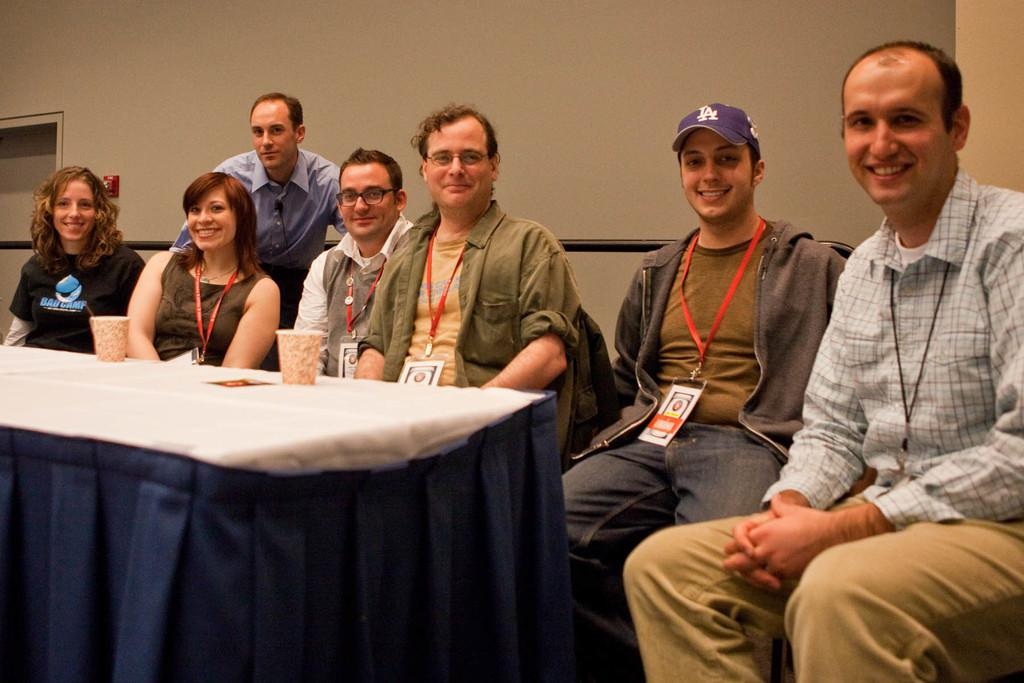Who or what is present in the image? There are people in the image. What are the people doing in the image? The people are sitting in front of a table. What objects can be seen on the table? There are coffee mugs on the table. What might indicate that the people in the image are part of an organization or workplace? The people are wearing ID cards. What type of crime is being committed in the image? There is no indication of a crime being committed in the image; it simply shows people sitting at a table with coffee mugs and wearing ID cards. 